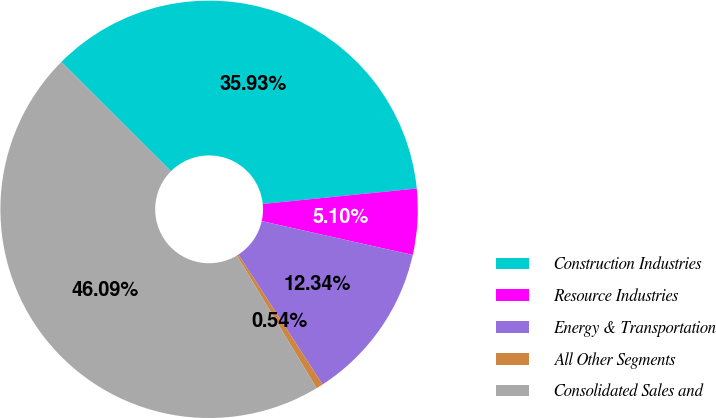Convert chart. <chart><loc_0><loc_0><loc_500><loc_500><pie_chart><fcel>Construction Industries<fcel>Resource Industries<fcel>Energy & Transportation<fcel>All Other Segments<fcel>Consolidated Sales and<nl><fcel>35.93%<fcel>5.1%<fcel>12.34%<fcel>0.54%<fcel>46.09%<nl></chart> 